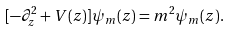<formula> <loc_0><loc_0><loc_500><loc_500>[ - \partial _ { z } ^ { 2 } + V ( z ) ] \psi _ { m } ( z ) = m ^ { 2 } \psi _ { m } ( z ) .</formula> 